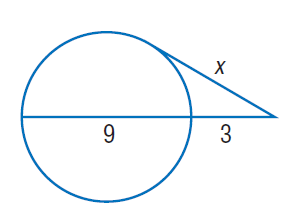Question: Find x. Round to the nearest tenth if necessary. Assume that segments that appear to be tangent are tangent.
Choices:
A. 3
B. 6
C. 9
D. 12
Answer with the letter. Answer: B 